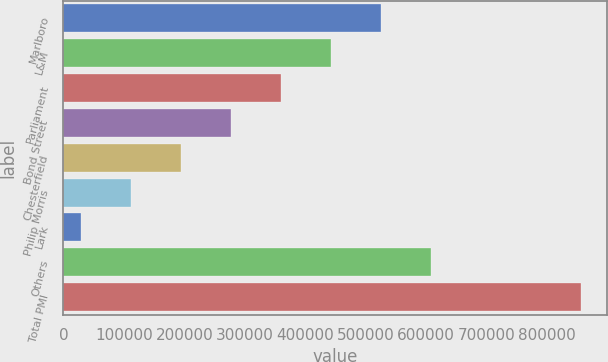Convert chart. <chart><loc_0><loc_0><loc_500><loc_500><bar_chart><fcel>Marlboro<fcel>L&M<fcel>Parliament<fcel>Bond Street<fcel>Chesterfield<fcel>Philip Morris<fcel>Lark<fcel>Others<fcel>Total PMI<nl><fcel>524962<fcel>442214<fcel>359465<fcel>276717<fcel>193969<fcel>111221<fcel>28473<fcel>607710<fcel>855954<nl></chart> 